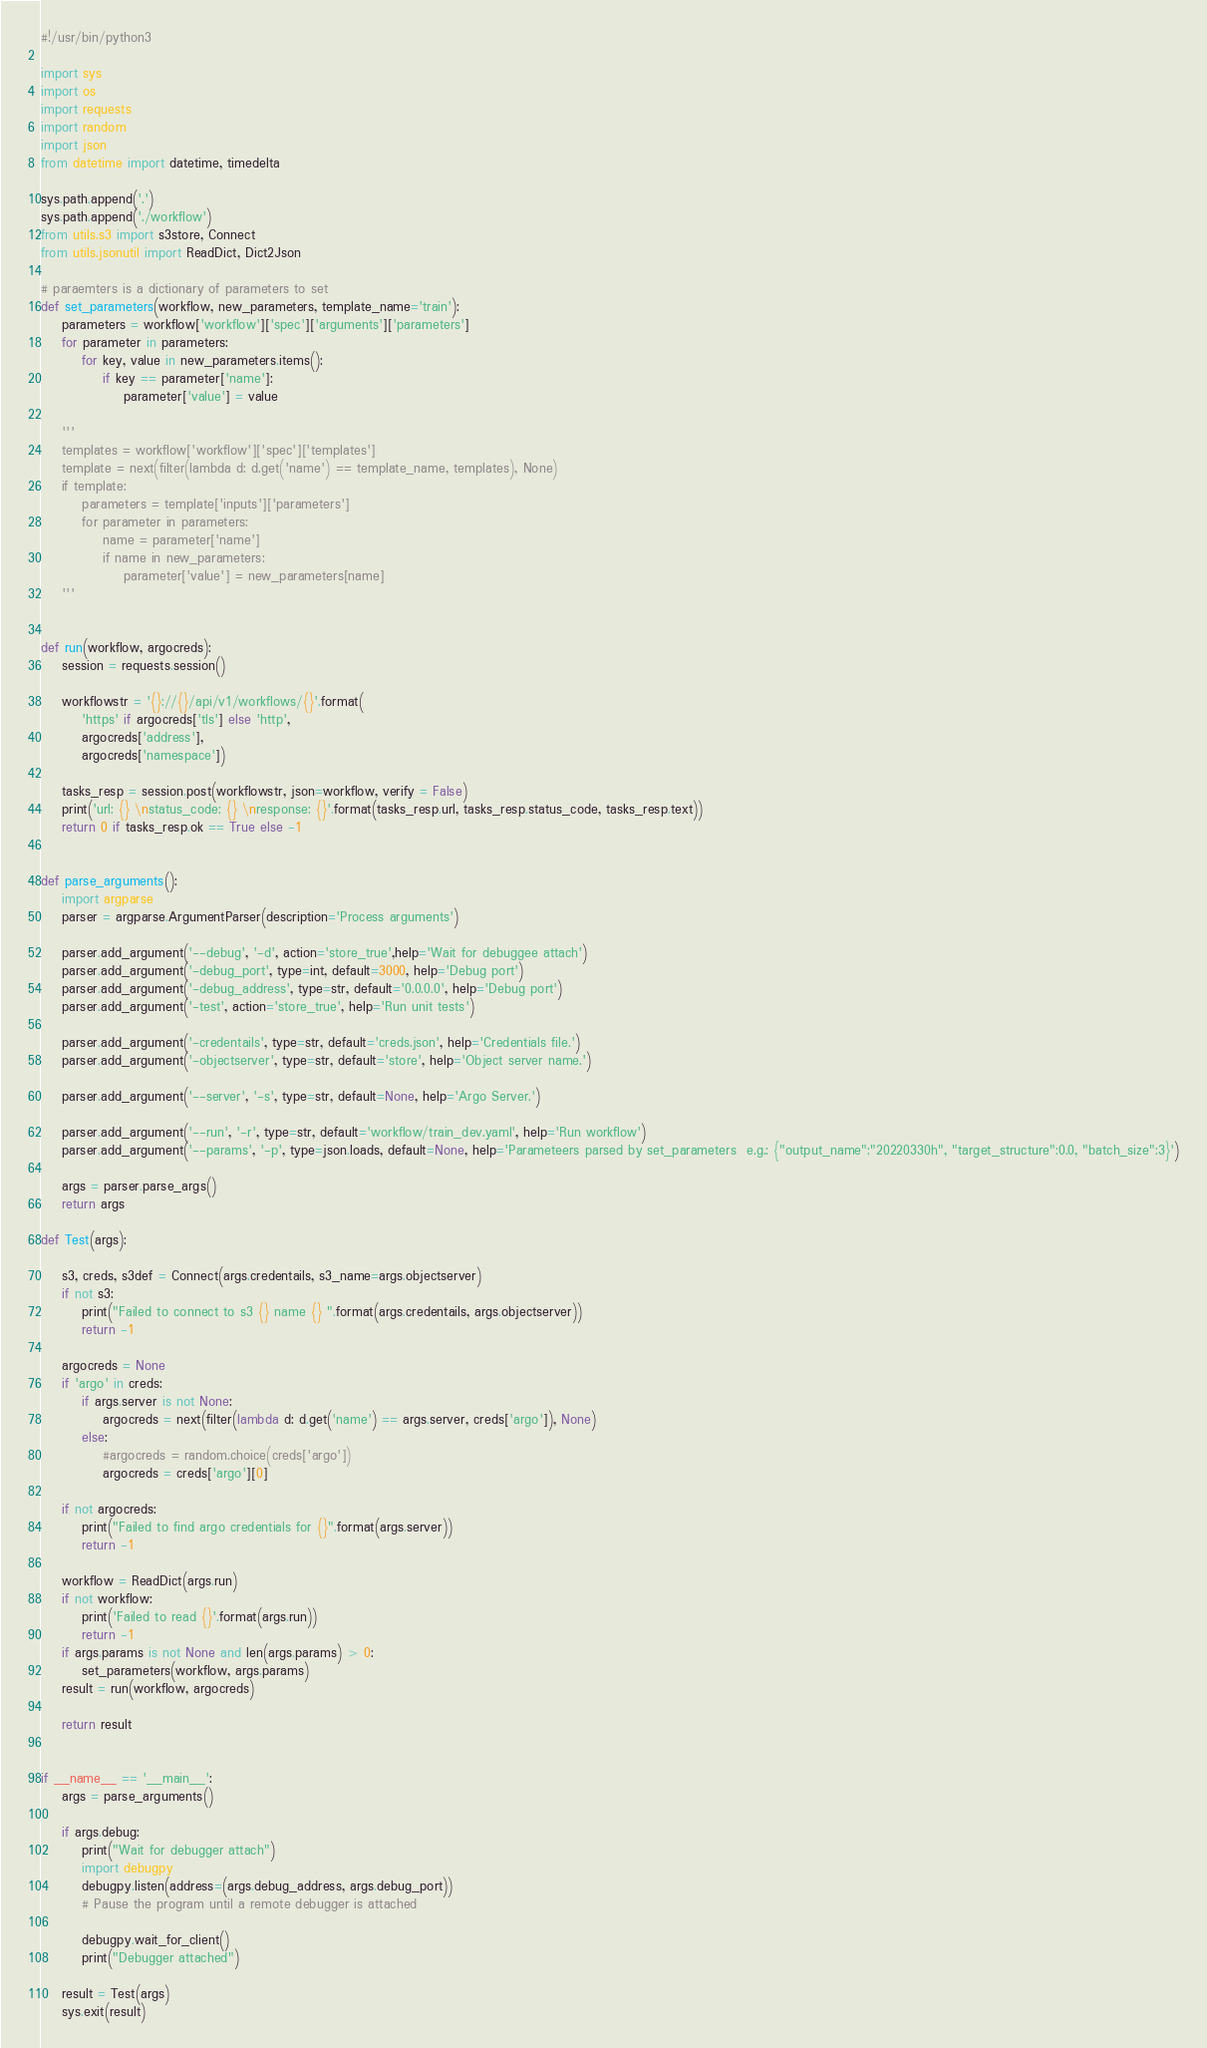Convert code to text. <code><loc_0><loc_0><loc_500><loc_500><_Python_>#!/usr/bin/python3

import sys
import os
import requests
import random
import json
from datetime import datetime, timedelta

sys.path.append('.')
sys.path.append('./workflow')
from utils.s3 import s3store, Connect
from utils.jsonutil import ReadDict, Dict2Json

# paraemters is a dictionary of parameters to set
def set_parameters(workflow, new_parameters, template_name='train'):
    parameters = workflow['workflow']['spec']['arguments']['parameters']
    for parameter in parameters:
        for key, value in new_parameters.items():
            if key == parameter['name']:
                parameter['value'] = value

    '''
    templates = workflow['workflow']['spec']['templates']
    template = next(filter(lambda d: d.get('name') == template_name, templates), None)
    if template:
        parameters = template['inputs']['parameters']
        for parameter in parameters:
            name = parameter['name']
            if name in new_parameters:
                parameter['value'] = new_parameters[name]
    '''


def run(workflow, argocreds):
    session = requests.session()

    workflowstr = '{}://{}/api/v1/workflows/{}'.format(
        'https' if argocreds['tls'] else 'http',
        argocreds['address'],
        argocreds['namespace'])

    tasks_resp = session.post(workflowstr, json=workflow, verify = False)
    print('url: {} \nstatus_code: {} \nresponse: {}'.format(tasks_resp.url, tasks_resp.status_code, tasks_resp.text))
    return 0 if tasks_resp.ok == True else -1 


def parse_arguments():
    import argparse
    parser = argparse.ArgumentParser(description='Process arguments')

    parser.add_argument('--debug', '-d', action='store_true',help='Wait for debuggee attach')   
    parser.add_argument('-debug_port', type=int, default=3000, help='Debug port')
    parser.add_argument('-debug_address', type=str, default='0.0.0.0', help='Debug port')
    parser.add_argument('-test', action='store_true', help='Run unit tests')

    parser.add_argument('-credentails', type=str, default='creds.json', help='Credentials file.')
    parser.add_argument('-objectserver', type=str, default='store', help='Object server name.')

    parser.add_argument('--server', '-s', type=str, default=None, help='Argo Server.')

    parser.add_argument('--run', '-r', type=str, default='workflow/train_dev.yaml', help='Run workflow')
    parser.add_argument('--params', '-p', type=json.loads, default=None, help='Parameteers parsed by set_parameters  e.g.: {"output_name":"20220330h", "target_structure":0.0, "batch_size":3}')

    args = parser.parse_args()
    return args

def Test(args):

    s3, creds, s3def = Connect(args.credentails, s3_name=args.objectserver)
    if not s3:
        print("Failed to connect to s3 {} name {} ".format(args.credentails, args.objectserver))
        return -1

    argocreds = None
    if 'argo' in creds:
        if args.server is not None:
            argocreds = next(filter(lambda d: d.get('name') == args.server, creds['argo']), None)
        else:
            #argocreds = random.choice(creds['argo'])
            argocreds = creds['argo'][0]

    if not argocreds:
        print("Failed to find argo credentials for {}".format(args.server))
        return -1

    workflow = ReadDict(args.run)
    if not workflow:
        print('Failed to read {}'.format(args.run))
        return -1
    if args.params is not None and len(args.params) > 0:
        set_parameters(workflow, args.params)
    result = run(workflow, argocreds)

    return result


if __name__ == '__main__':
    args = parse_arguments()

    if args.debug:
        print("Wait for debugger attach")
        import debugpy
        debugpy.listen(address=(args.debug_address, args.debug_port))
        # Pause the program until a remote debugger is attached

        debugpy.wait_for_client()
        print("Debugger attached")

    result = Test(args)
    sys.exit(result)</code> 